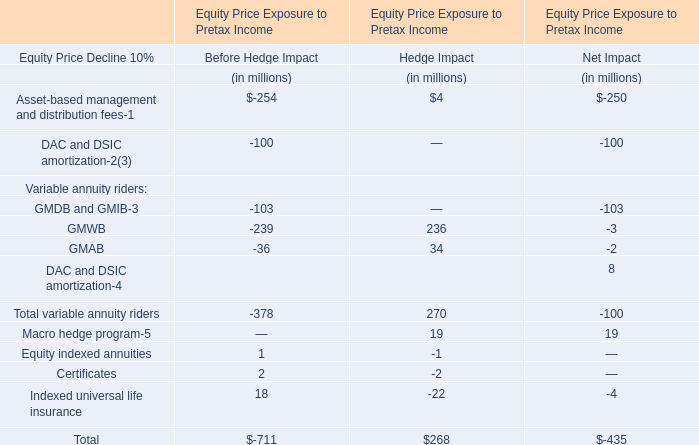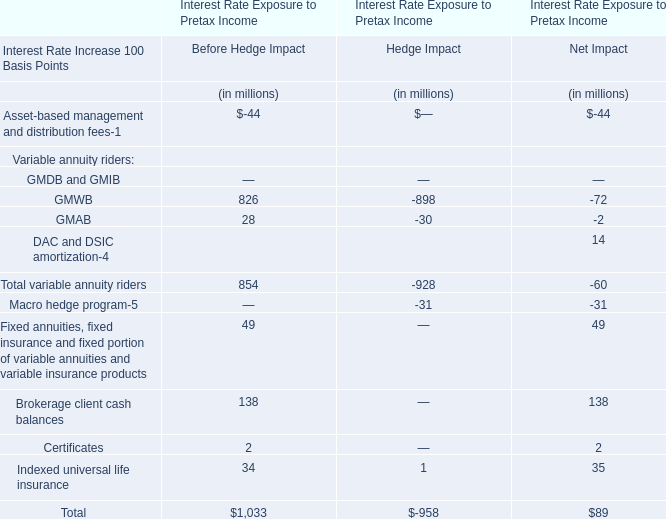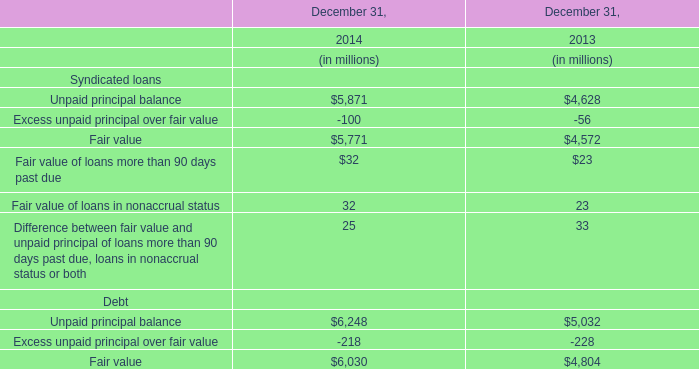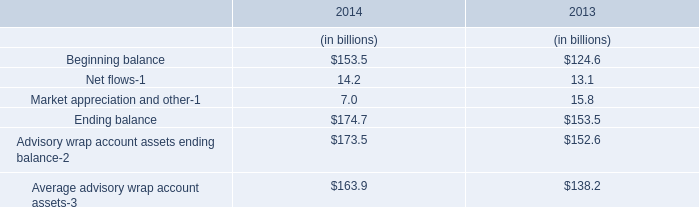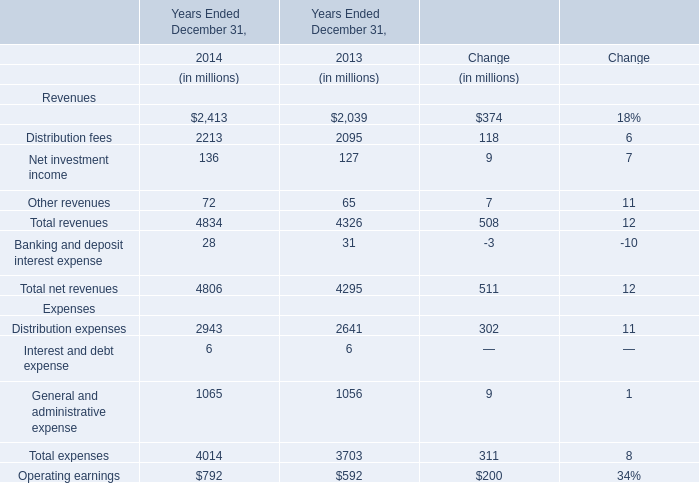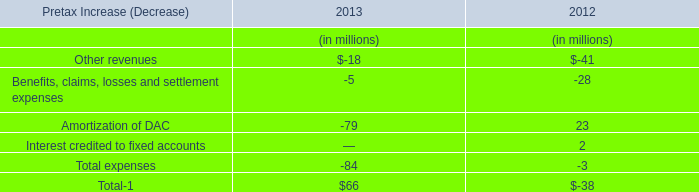What is the proportion of Net investment income to the total in 2014? 
Computations: (136 / 4834)
Answer: 0.02813. 